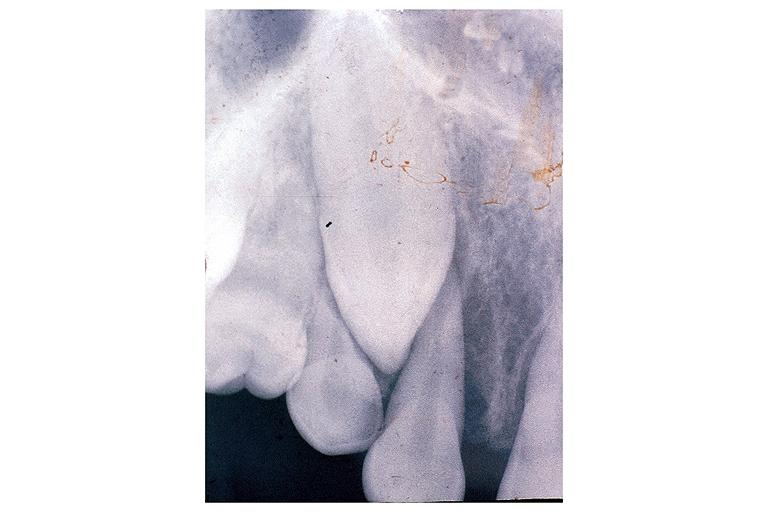does this image show osteosarcoma?
Answer the question using a single word or phrase. Yes 